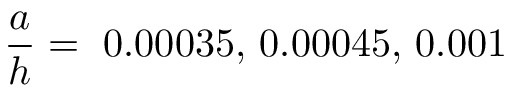Convert formula to latex. <formula><loc_0><loc_0><loc_500><loc_500>\frac { a } { h } = 0 . 0 0 0 3 5 , 0 . 0 0 0 4 5 , 0 . 0 0 1</formula> 